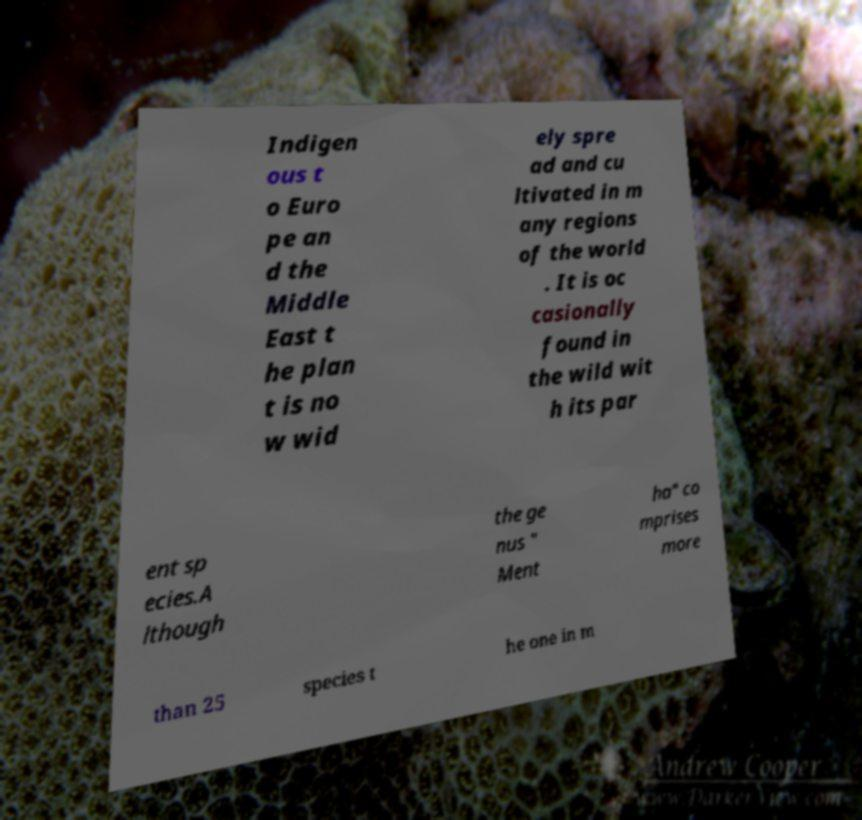For documentation purposes, I need the text within this image transcribed. Could you provide that? Indigen ous t o Euro pe an d the Middle East t he plan t is no w wid ely spre ad and cu ltivated in m any regions of the world . It is oc casionally found in the wild wit h its par ent sp ecies.A lthough the ge nus " Ment ha" co mprises more than 25 species t he one in m 